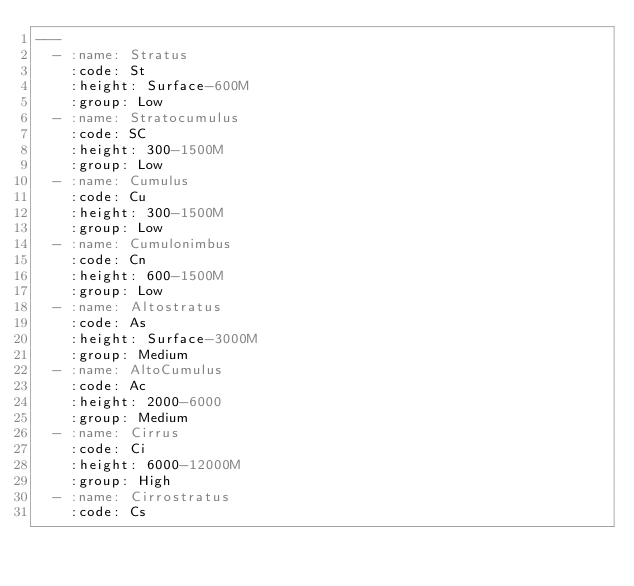<code> <loc_0><loc_0><loc_500><loc_500><_YAML_>---
  - :name: Stratus
    :code: St
    :height: Surface-600M
    :group: Low
  - :name: Stratocumulus
    :code: SC
    :height: 300-1500M
    :group: Low
  - :name: Cumulus
    :code: Cu
    :height: 300-1500M
    :group: Low
  - :name: Cumulonimbus
    :code: Cn
    :height: 600-1500M
    :group: Low
  - :name: Altostratus
    :code: As
    :height: Surface-3000M
    :group: Medium
  - :name: AltoCumulus
    :code: Ac
    :height: 2000-6000
    :group: Medium
  - :name: Cirrus
    :code: Ci
    :height: 6000-12000M
    :group: High
  - :name: Cirrostratus
    :code: Cs</code> 